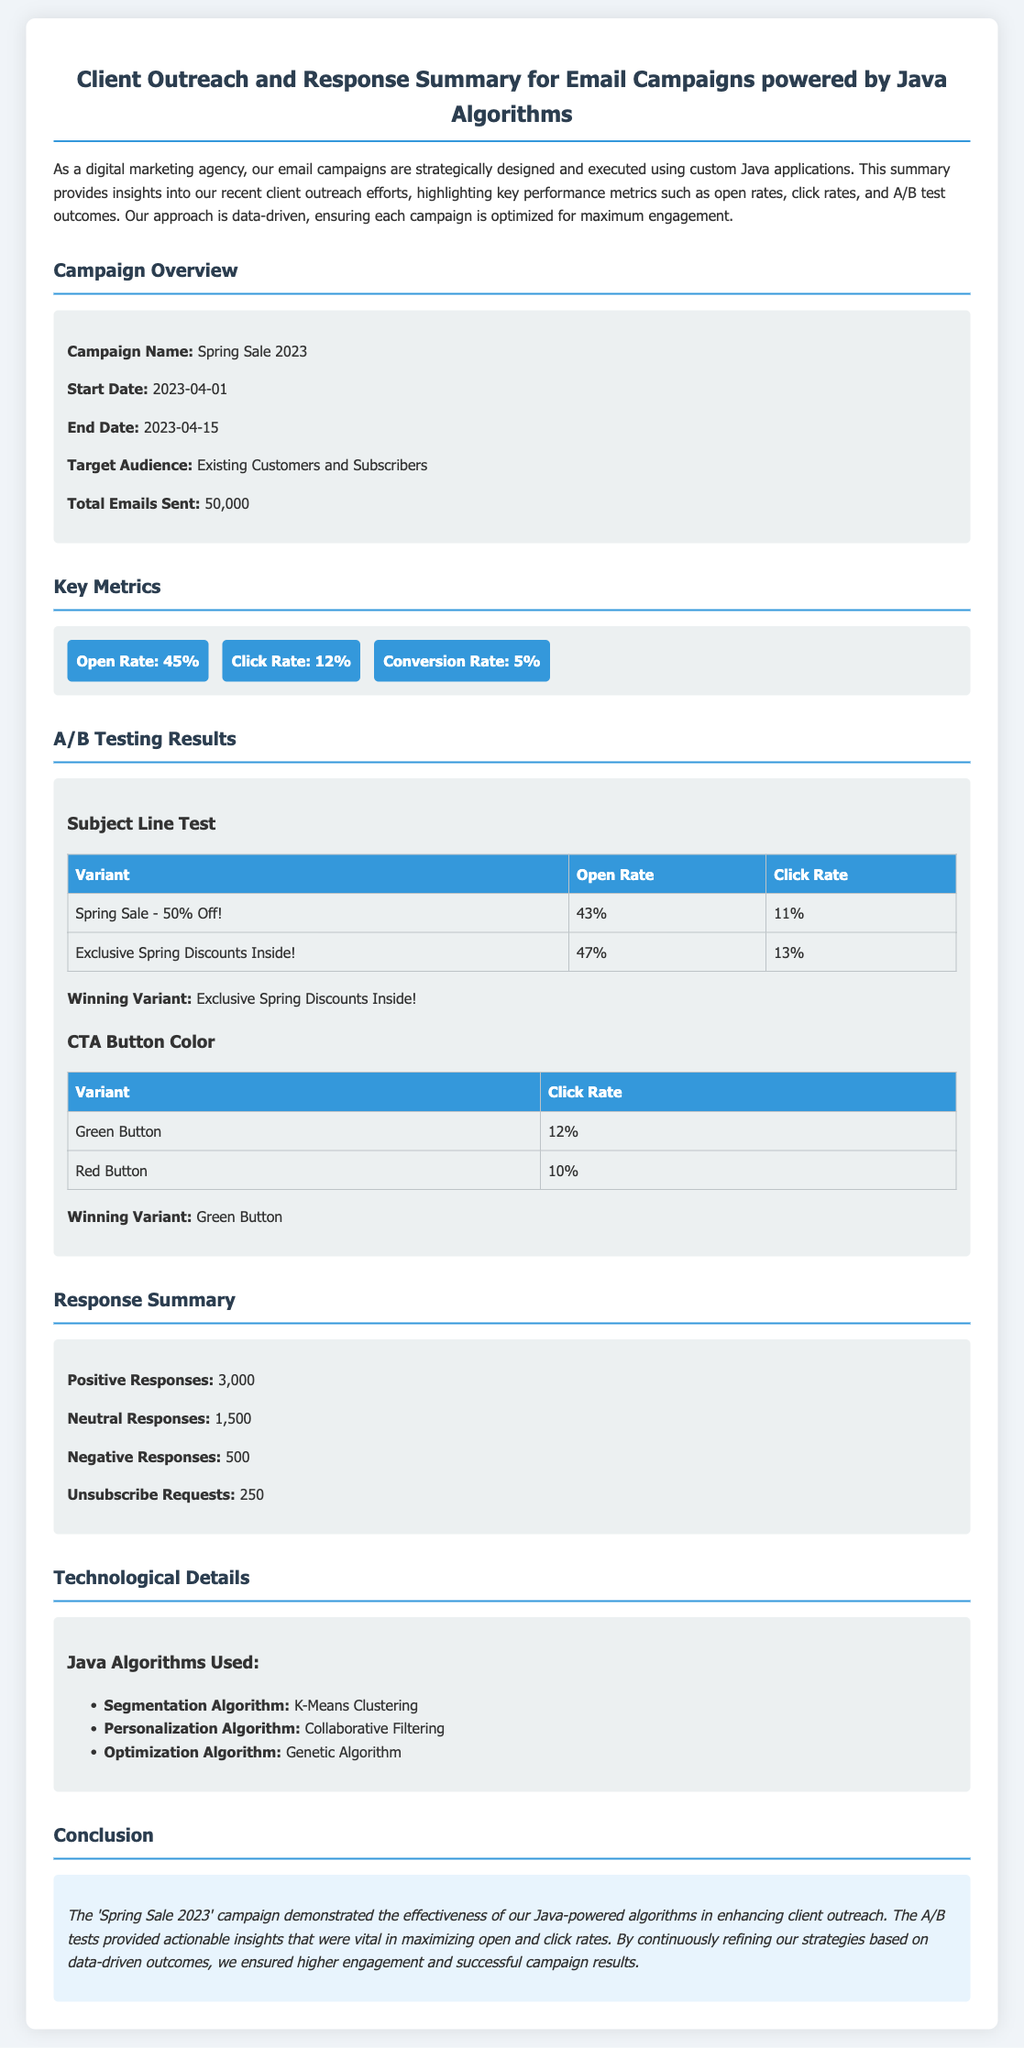What is the campaign name? The campaign name is mentioned in the overview section, which is "Spring Sale 2023."
Answer: Spring Sale 2023 What were the total emails sent during the campaign? The total emails sent figure is provided in the campaign overview as "50,000."
Answer: 50,000 What was the open rate for the email campaign? The open rate is listed in the key metrics section as "45%."
Answer: 45% Who was the target audience for the campaign? The target audience is specified in the campaign overview section as "Existing Customers and Subscribers."
Answer: Existing Customers and Subscribers Which subject line variant had the highest open rate? The winning variant with the highest open rate is found in the A/B testing results section under Subject Line Test.
Answer: Exclusive Spring Discounts Inside! What was the click rate for the green button variant in the A/B testing? The click rate for the green button variant is shown in the A/B testing results section as "12%."
Answer: 12% How many positive responses were received from the campaign? The count of positive responses is stated in the response summary section as "3,000."
Answer: 3,000 What optimization algorithm was used in the campaign? The optimization algorithm is listed in the technological details section as "Genetic Algorithm."
Answer: Genetic Algorithm What percentage of recipients opted out of the campaign? The unsubscribe requests are given in the response summary section allowing calculation of the percentage from total emails sent.
Answer: 0.5% 